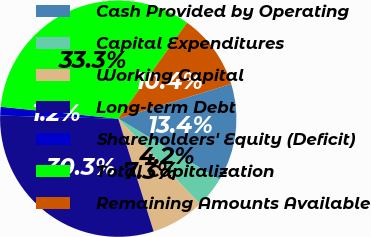Convert chart. <chart><loc_0><loc_0><loc_500><loc_500><pie_chart><fcel>Cash Provided by Operating<fcel>Capital Expenditures<fcel>Working Capital<fcel>Long-term Debt<fcel>Shareholders' Equity (Deficit)<fcel>Total Capitalization<fcel>Remaining Amounts Available<nl><fcel>13.37%<fcel>4.22%<fcel>7.32%<fcel>30.26%<fcel>1.19%<fcel>33.29%<fcel>10.35%<nl></chart> 